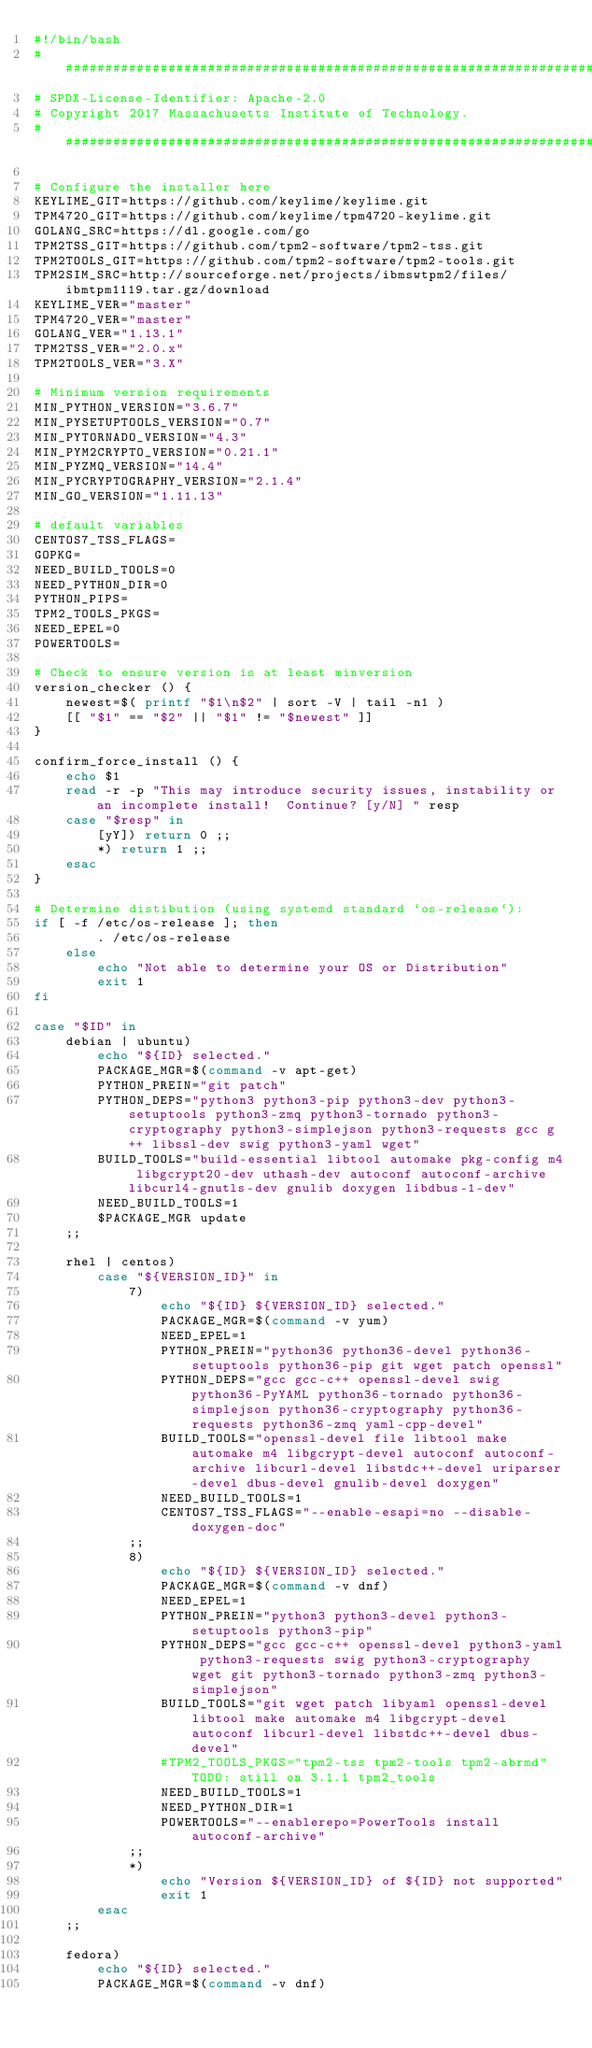Convert code to text. <code><loc_0><loc_0><loc_500><loc_500><_Bash_>#!/bin/bash
################################################################################
# SPDX-License-Identifier: Apache-2.0
# Copyright 2017 Massachusetts Institute of Technology.
################################################################################

# Configure the installer here
KEYLIME_GIT=https://github.com/keylime/keylime.git
TPM4720_GIT=https://github.com/keylime/tpm4720-keylime.git
GOLANG_SRC=https://dl.google.com/go
TPM2TSS_GIT=https://github.com/tpm2-software/tpm2-tss.git
TPM2TOOLS_GIT=https://github.com/tpm2-software/tpm2-tools.git
TPM2SIM_SRC=http://sourceforge.net/projects/ibmswtpm2/files/ibmtpm1119.tar.gz/download
KEYLIME_VER="master"
TPM4720_VER="master"
GOLANG_VER="1.13.1"
TPM2TSS_VER="2.0.x"
TPM2TOOLS_VER="3.X"

# Minimum version requirements
MIN_PYTHON_VERSION="3.6.7"
MIN_PYSETUPTOOLS_VERSION="0.7"
MIN_PYTORNADO_VERSION="4.3"
MIN_PYM2CRYPTO_VERSION="0.21.1"
MIN_PYZMQ_VERSION="14.4"
MIN_PYCRYPTOGRAPHY_VERSION="2.1.4"
MIN_GO_VERSION="1.11.13"

# default variables
CENTOS7_TSS_FLAGS=
GOPKG=
NEED_BUILD_TOOLS=0
NEED_PYTHON_DIR=0
PYTHON_PIPS=
TPM2_TOOLS_PKGS=
NEED_EPEL=0
POWERTOOLS=

# Check to ensure version is at least minversion
version_checker () {
    newest=$( printf "$1\n$2" | sort -V | tail -n1 )
    [[ "$1" == "$2" || "$1" != "$newest" ]]
}

confirm_force_install () {
    echo $1
    read -r -p "This may introduce security issues, instability or an incomplete install!  Continue? [y/N] " resp
    case "$resp" in
        [yY]) return 0 ;;
        *) return 1 ;;
    esac
}

# Determine distibution (using systemd standard `os-release`):
if [ -f /etc/os-release ]; then
        . /etc/os-release
    else
        echo "Not able to determine your OS or Distribution"
        exit 1
fi

case "$ID" in
    debian | ubuntu)
        echo "${ID} selected."
        PACKAGE_MGR=$(command -v apt-get)
        PYTHON_PREIN="git patch"
        PYTHON_DEPS="python3 python3-pip python3-dev python3-setuptools python3-zmq python3-tornado python3-cryptography python3-simplejson python3-requests gcc g++ libssl-dev swig python3-yaml wget"
        BUILD_TOOLS="build-essential libtool automake pkg-config m4 libgcrypt20-dev uthash-dev autoconf autoconf-archive libcurl4-gnutls-dev gnulib doxygen libdbus-1-dev"
        NEED_BUILD_TOOLS=1
        $PACKAGE_MGR update
    ;;

    rhel | centos)
        case "${VERSION_ID}" in
            7)
                echo "${ID} ${VERSION_ID} selected."
                PACKAGE_MGR=$(command -v yum)
                NEED_EPEL=1
                PYTHON_PREIN="python36 python36-devel python36-setuptools python36-pip git wget patch openssl"
                PYTHON_DEPS="gcc gcc-c++ openssl-devel swig python36-PyYAML python36-tornado python36-simplejson python36-cryptography python36-requests python36-zmq yaml-cpp-devel"
                BUILD_TOOLS="openssl-devel file libtool make automake m4 libgcrypt-devel autoconf autoconf-archive libcurl-devel libstdc++-devel uriparser-devel dbus-devel gnulib-devel doxygen"
                NEED_BUILD_TOOLS=1
                CENTOS7_TSS_FLAGS="--enable-esapi=no --disable-doxygen-doc"
            ;;
            8)
                echo "${ID} ${VERSION_ID} selected."
                PACKAGE_MGR=$(command -v dnf)
                NEED_EPEL=1
                PYTHON_PREIN="python3 python3-devel python3-setuptools python3-pip"
                PYTHON_DEPS="gcc gcc-c++ openssl-devel python3-yaml python3-requests swig python3-cryptography wget git python3-tornado python3-zmq python3-simplejson"
                BUILD_TOOLS="git wget patch libyaml openssl-devel libtool make automake m4 libgcrypt-devel autoconf libcurl-devel libstdc++-devel dbus-devel"
                #TPM2_TOOLS_PKGS="tpm2-tss tpm2-tools tpm2-abrmd" TODO: still on 3.1.1 tpm2_tools
                NEED_BUILD_TOOLS=1
                NEED_PYTHON_DIR=1
                POWERTOOLS="--enablerepo=PowerTools install autoconf-archive"
            ;;
            *)
                echo "Version ${VERSION_ID} of ${ID} not supported"
                exit 1
        esac
    ;;

    fedora)
        echo "${ID} selected."
        PACKAGE_MGR=$(command -v dnf)</code> 